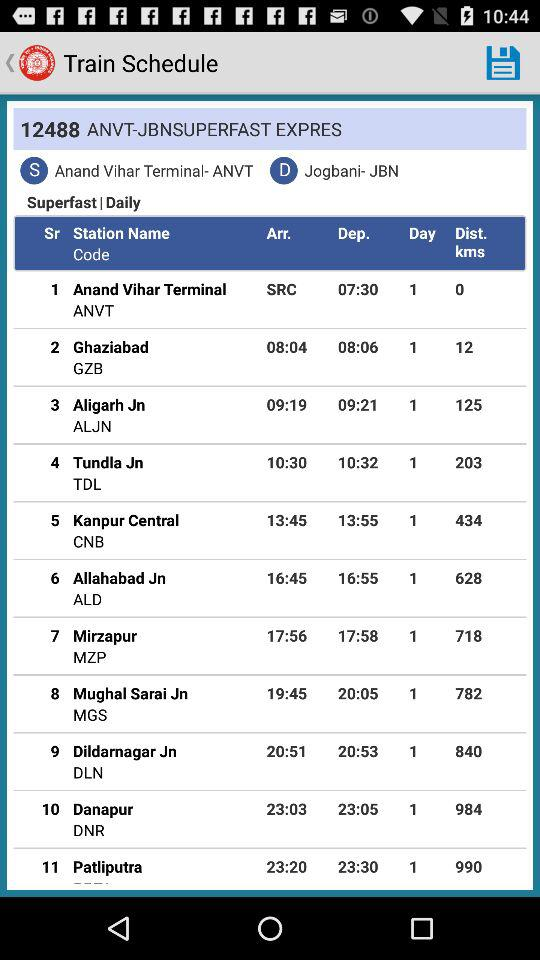What is the train name? The train name is "ANVT-JBNSUPERFAST EXPRES". 